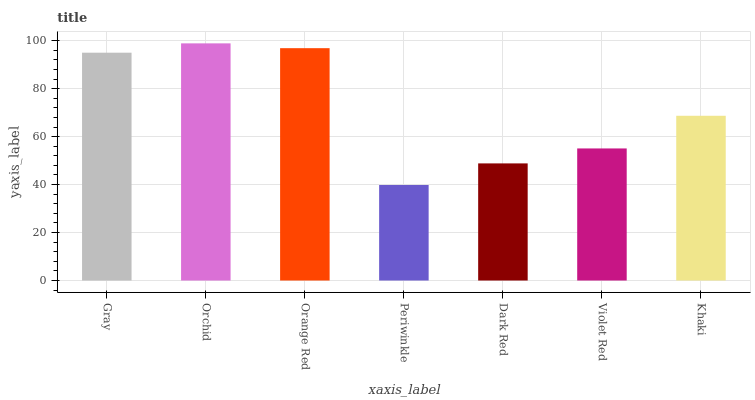Is Periwinkle the minimum?
Answer yes or no. Yes. Is Orchid the maximum?
Answer yes or no. Yes. Is Orange Red the minimum?
Answer yes or no. No. Is Orange Red the maximum?
Answer yes or no. No. Is Orchid greater than Orange Red?
Answer yes or no. Yes. Is Orange Red less than Orchid?
Answer yes or no. Yes. Is Orange Red greater than Orchid?
Answer yes or no. No. Is Orchid less than Orange Red?
Answer yes or no. No. Is Khaki the high median?
Answer yes or no. Yes. Is Khaki the low median?
Answer yes or no. Yes. Is Orchid the high median?
Answer yes or no. No. Is Dark Red the low median?
Answer yes or no. No. 